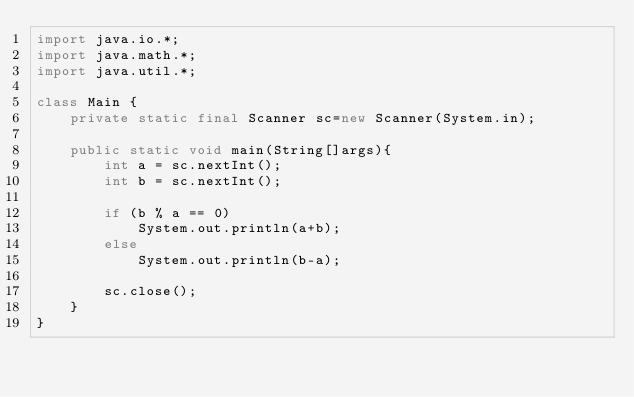<code> <loc_0><loc_0><loc_500><loc_500><_Java_>import java.io.*;
import java.math.*;
import java.util.*;

class Main {
    private static final Scanner sc=new Scanner(System.in);

    public static void main(String[]args){
        int a = sc.nextInt();
        int b = sc.nextInt();

        if (b % a == 0)
            System.out.println(a+b);
        else
            System.out.println(b-a);

        sc.close();
    }
}</code> 